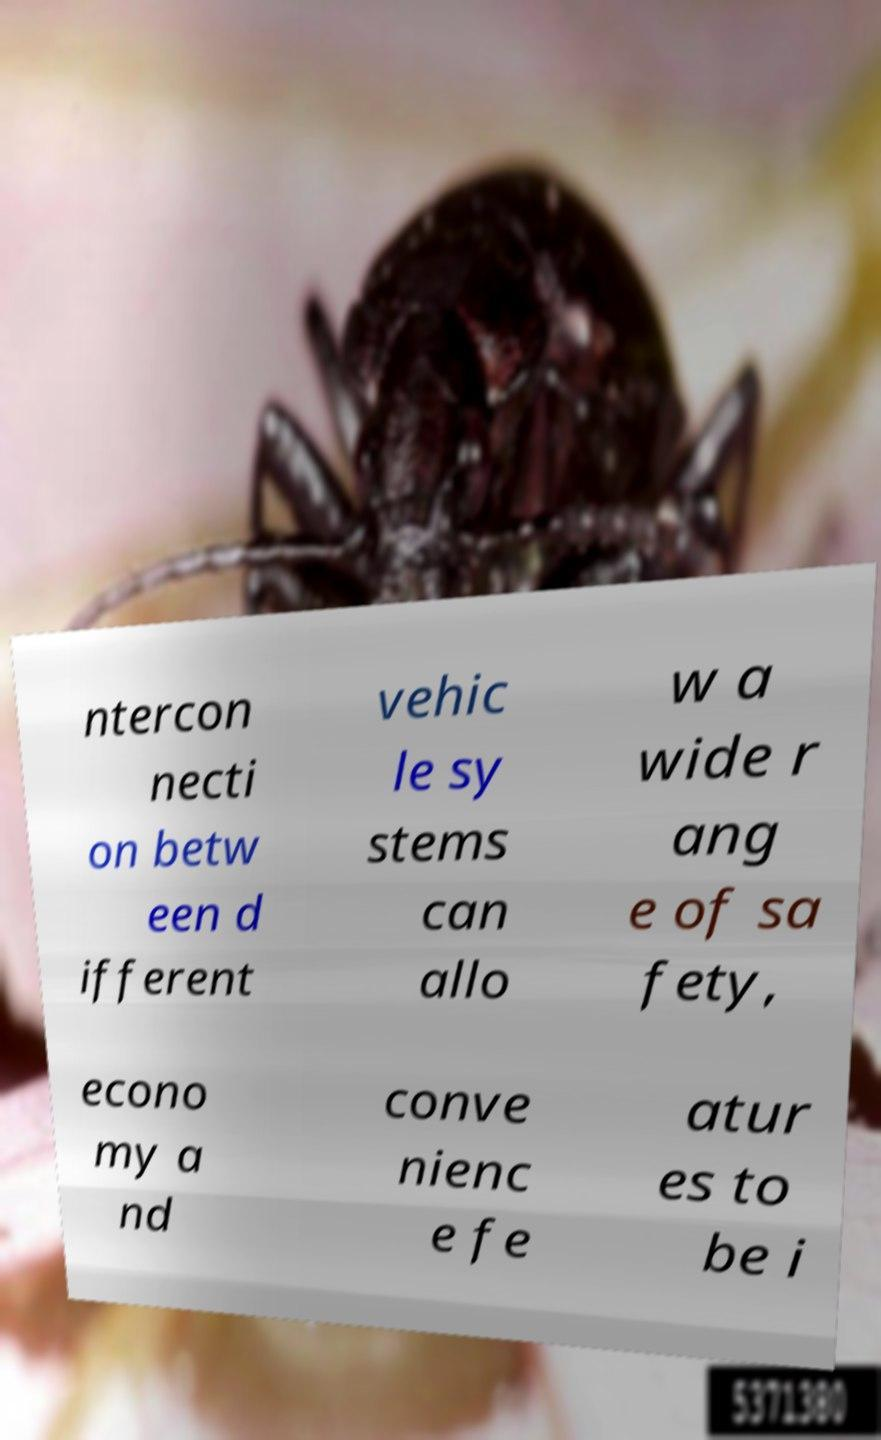Could you assist in decoding the text presented in this image and type it out clearly? ntercon necti on betw een d ifferent vehic le sy stems can allo w a wide r ang e of sa fety, econo my a nd conve nienc e fe atur es to be i 